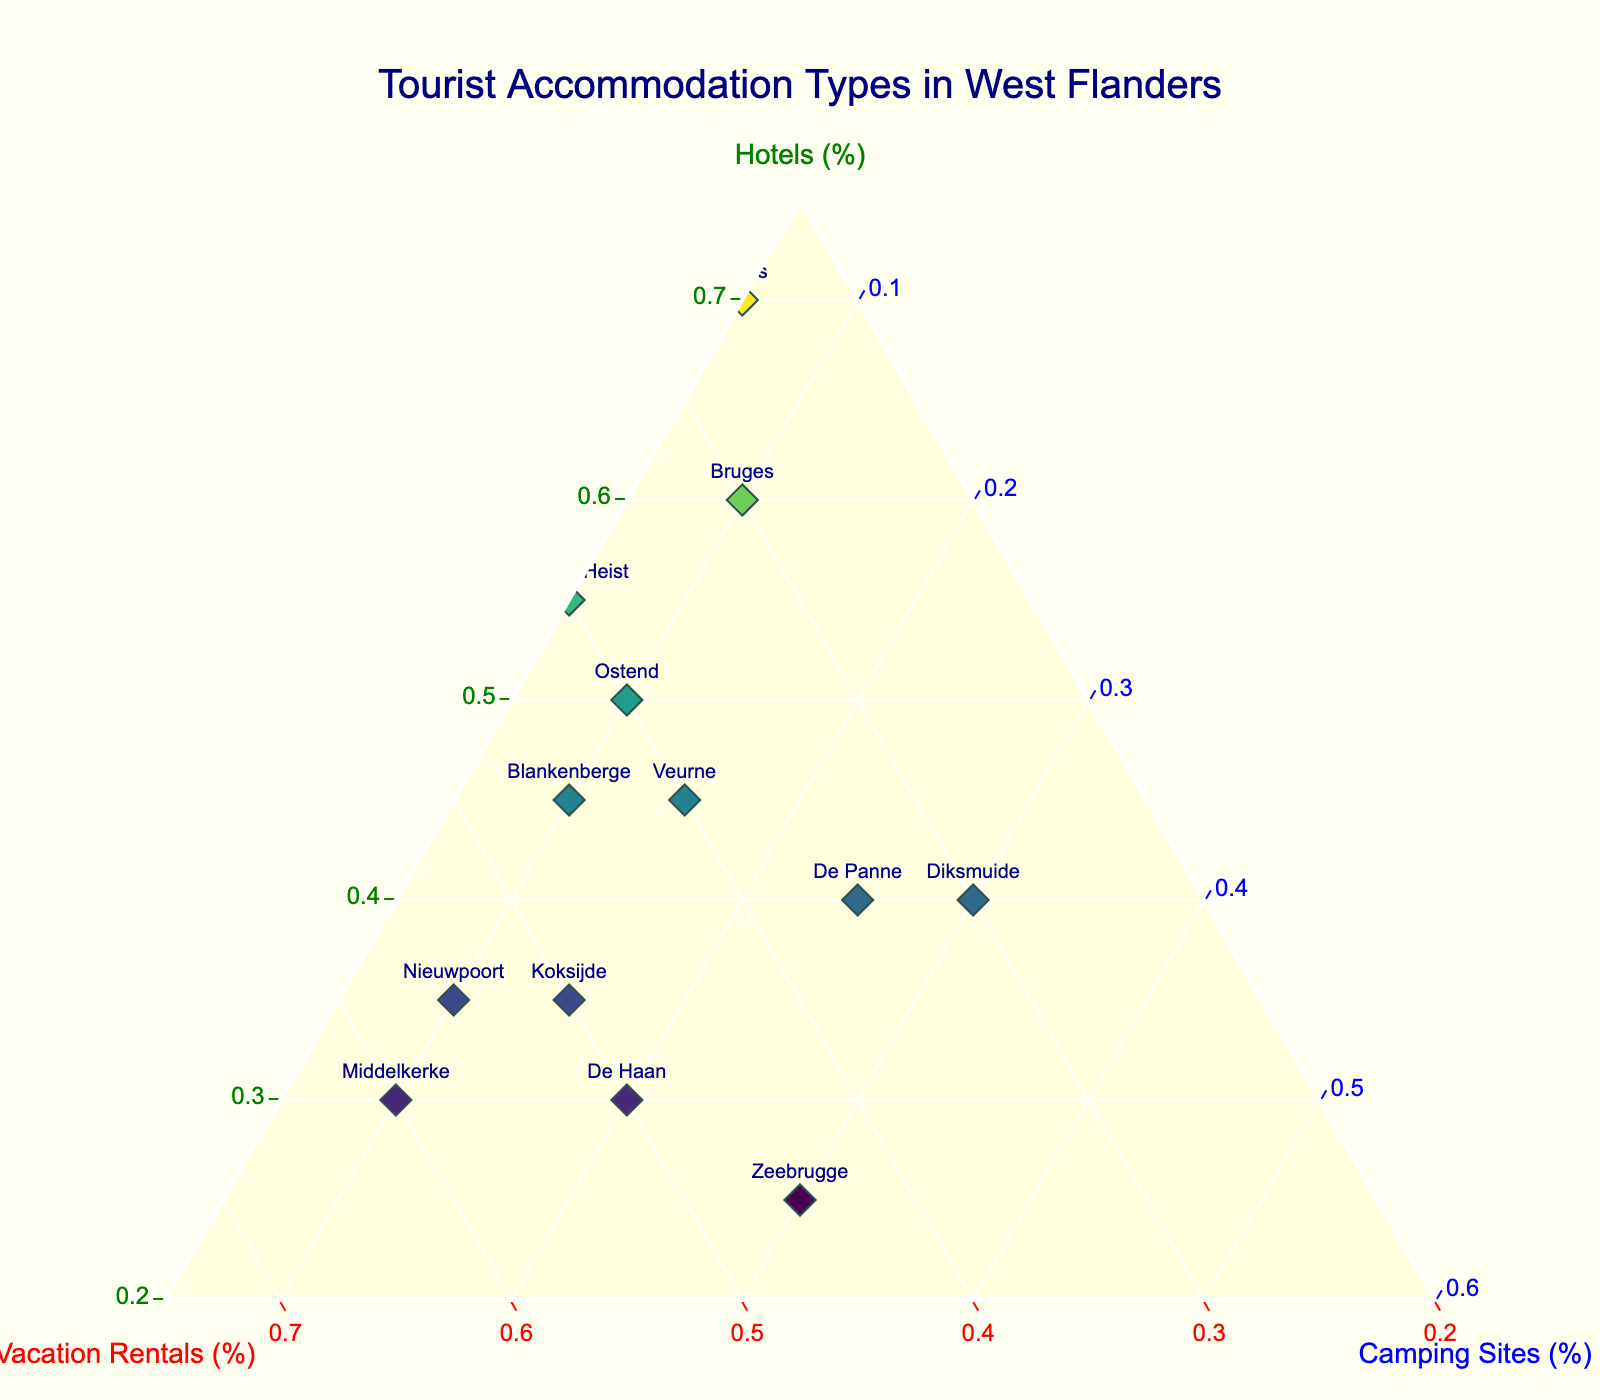What is the title of the figure? The title is usually found at the top center of the figure.
Answer: Tourist Accommodation Types in West Flanders How many accommodation types are depicted in the ternary plot? The ternary plot shows three accommodation types: hotels, vacation rentals, and camping sites.
Answer: Three Which location has the highest percentage of camping sites? By observing the plotting points and text labels, Zeebrugge has the highest percentage of camping sites at 30%.
Answer: Zeebrugge What is the percentage of vacation rentals in Middelkerke? In the ternary plot, find the point labeled "Middelkerke" and check the hovertemplate or the data provided. Middelkerke has 60%.
Answer: 60% Which locations have the lowest percentage of hotels? Identify the locations with the smallest values on the hotels axis. Zeebrugge and De Haan both have 25% and 30% respectively.
Answer: Zeebrugge and De Haan Compare the accommodation types between Bruges and Ypres. Which one has a higher percentage of hotels? Locate the points for Bruges and Ypres. Bruges has 60% hotels, while Ypres has 70%. Therefore, Ypres has a higher percentage of hotels.
Answer: Ypres Calculate the average percentage of vacation rentals in the following locations: Nieuwpoort, Koksijde, and De Panne. Add the percentages of vacation rentals for these three locations (55 + 50 + 35) and then divide by the number of locations (3). (55 + 50 + 35) / 3 = 140 / 3 = 46.67%
Answer: 46.67% Among the listed locations, which one has a more balanced distribution among the three accommodation types? From the ternary plot, Diksmuide stands out with 40% hotels, 30% vacation rentals, and 30% camping sites, which appear relatively balanced.
Answer: Diksmuide Are there any locations where the percentage of vacation rentals is greater than the combined percentage of hotels and camping sites? Check if the vacation rentals percentage is higher than the sum of hotels and camping sites for any location. Middelkerke has 60% vacation rentals, and the sum of hotels (30%) and camping sites (10%) is 40%, which is lower.
Answer: Middelkerke 